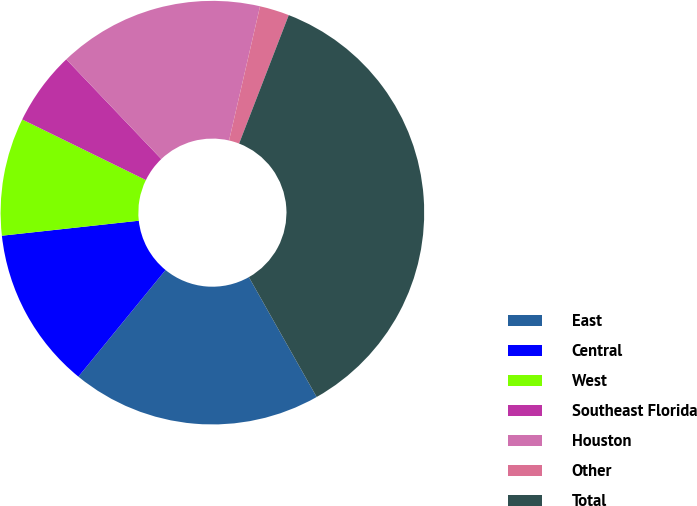Convert chart to OTSL. <chart><loc_0><loc_0><loc_500><loc_500><pie_chart><fcel>East<fcel>Central<fcel>West<fcel>Southeast Florida<fcel>Houston<fcel>Other<fcel>Total<nl><fcel>19.1%<fcel>12.36%<fcel>8.99%<fcel>5.63%<fcel>15.73%<fcel>2.26%<fcel>35.94%<nl></chart> 